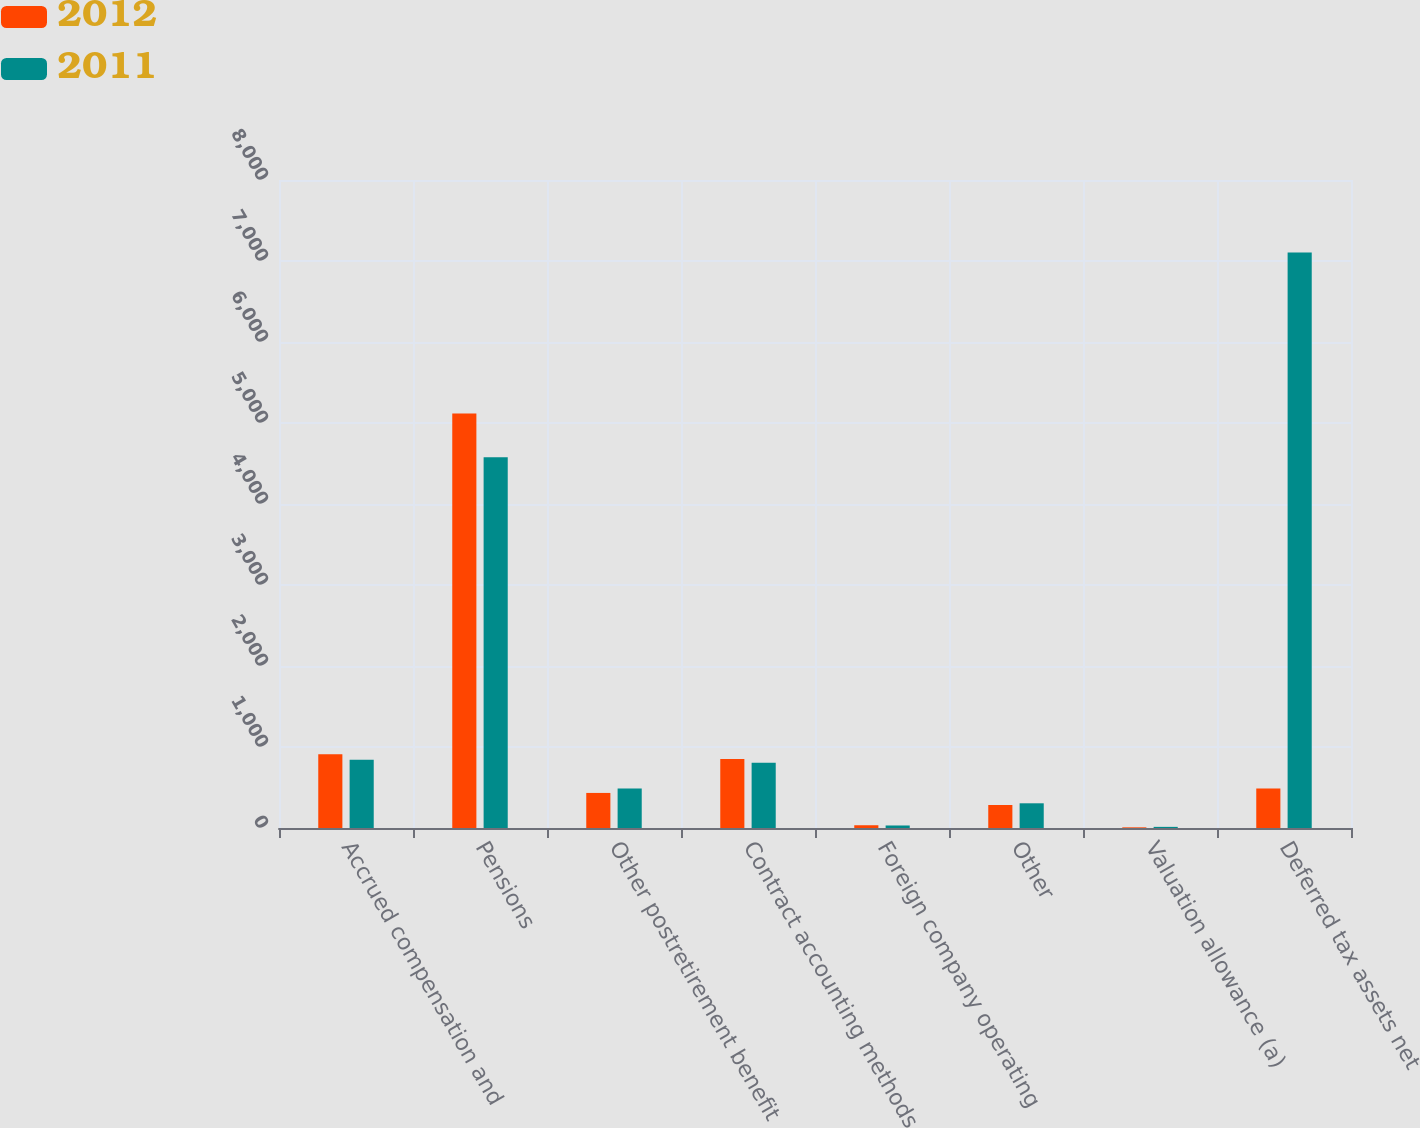Convert chart to OTSL. <chart><loc_0><loc_0><loc_500><loc_500><stacked_bar_chart><ecel><fcel>Accrued compensation and<fcel>Pensions<fcel>Other postretirement benefit<fcel>Contract accounting methods<fcel>Foreign company operating<fcel>Other<fcel>Valuation allowance (a)<fcel>Deferred tax assets net<nl><fcel>2012<fcel>909<fcel>5117<fcel>433<fcel>853<fcel>34<fcel>284<fcel>8<fcel>487<nl><fcel>2011<fcel>843<fcel>4578<fcel>487<fcel>806<fcel>31<fcel>305<fcel>14<fcel>7105<nl></chart> 